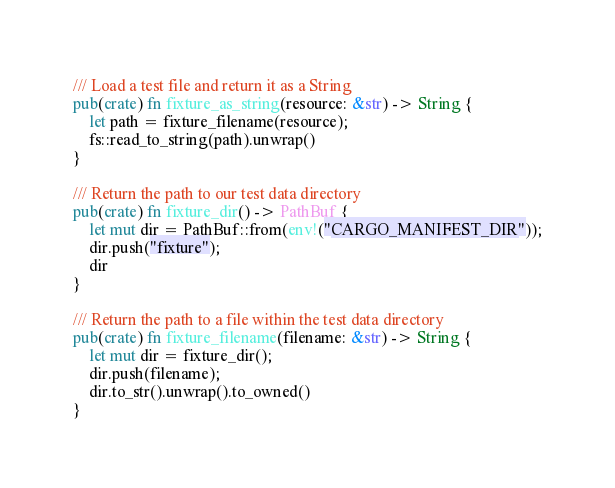<code> <loc_0><loc_0><loc_500><loc_500><_Rust_>
/// Load a test file and return it as a String
pub(crate) fn fixture_as_string(resource: &str) -> String {
    let path = fixture_filename(resource);
    fs::read_to_string(path).unwrap()
}

/// Return the path to our test data directory
pub(crate) fn fixture_dir() -> PathBuf {
    let mut dir = PathBuf::from(env!("CARGO_MANIFEST_DIR"));
    dir.push("fixture");
    dir
}

/// Return the path to a file within the test data directory
pub(crate) fn fixture_filename(filename: &str) -> String {
    let mut dir = fixture_dir();
    dir.push(filename);
    dir.to_str().unwrap().to_owned()
}
</code> 